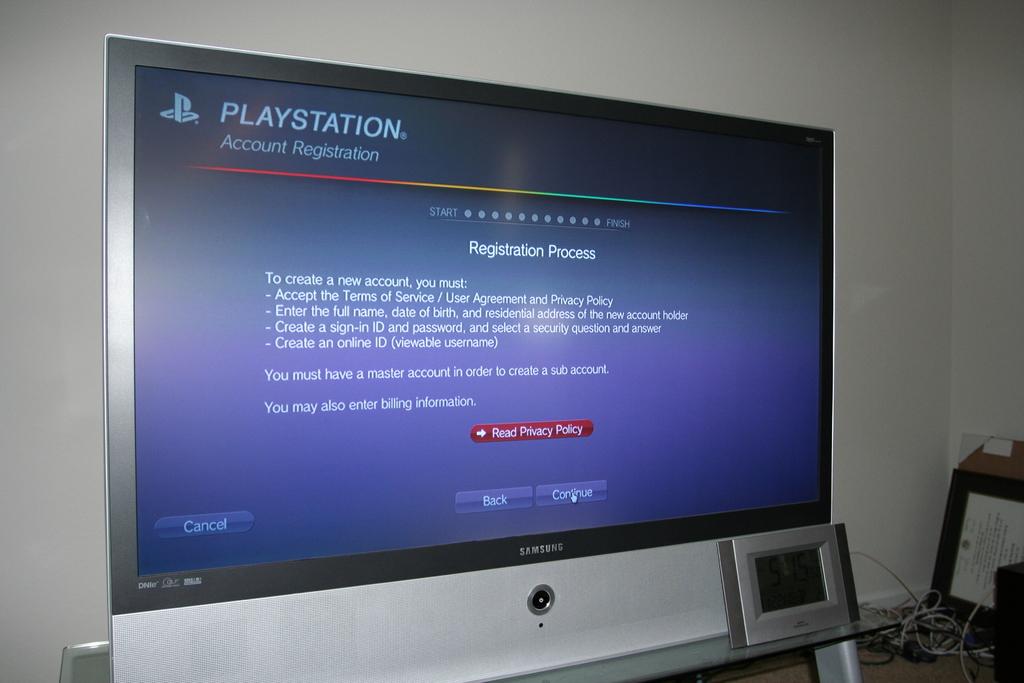What gaming system is this for?
Keep it short and to the point. Playstation. What process is this person going through?
Provide a succinct answer. Registration. 